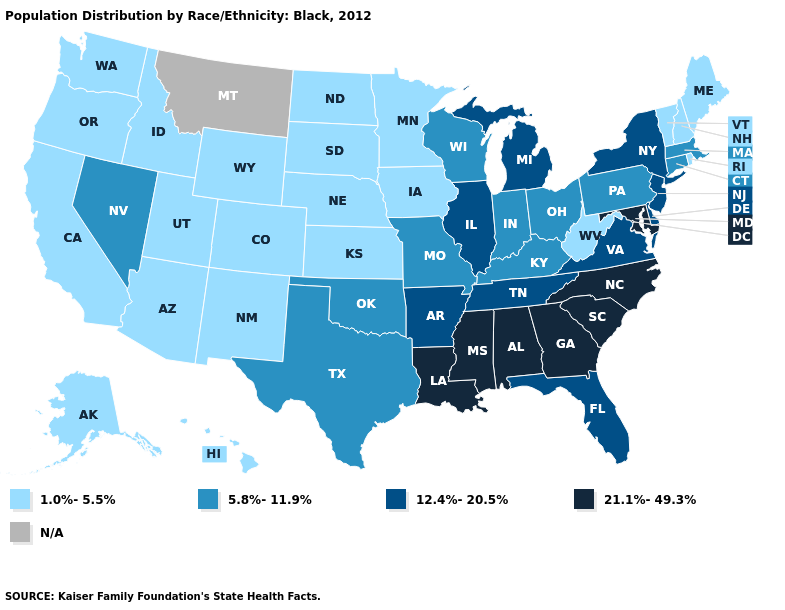What is the highest value in the USA?
Keep it brief. 21.1%-49.3%. Among the states that border Wisconsin , does Michigan have the highest value?
Short answer required. Yes. Name the states that have a value in the range 1.0%-5.5%?
Short answer required. Alaska, Arizona, California, Colorado, Hawaii, Idaho, Iowa, Kansas, Maine, Minnesota, Nebraska, New Hampshire, New Mexico, North Dakota, Oregon, Rhode Island, South Dakota, Utah, Vermont, Washington, West Virginia, Wyoming. Name the states that have a value in the range 5.8%-11.9%?
Be succinct. Connecticut, Indiana, Kentucky, Massachusetts, Missouri, Nevada, Ohio, Oklahoma, Pennsylvania, Texas, Wisconsin. Name the states that have a value in the range 12.4%-20.5%?
Concise answer only. Arkansas, Delaware, Florida, Illinois, Michigan, New Jersey, New York, Tennessee, Virginia. How many symbols are there in the legend?
Short answer required. 5. Name the states that have a value in the range N/A?
Quick response, please. Montana. Which states have the highest value in the USA?
Answer briefly. Alabama, Georgia, Louisiana, Maryland, Mississippi, North Carolina, South Carolina. Which states have the lowest value in the USA?
Quick response, please. Alaska, Arizona, California, Colorado, Hawaii, Idaho, Iowa, Kansas, Maine, Minnesota, Nebraska, New Hampshire, New Mexico, North Dakota, Oregon, Rhode Island, South Dakota, Utah, Vermont, Washington, West Virginia, Wyoming. What is the value of South Carolina?
Concise answer only. 21.1%-49.3%. Name the states that have a value in the range 1.0%-5.5%?
Be succinct. Alaska, Arizona, California, Colorado, Hawaii, Idaho, Iowa, Kansas, Maine, Minnesota, Nebraska, New Hampshire, New Mexico, North Dakota, Oregon, Rhode Island, South Dakota, Utah, Vermont, Washington, West Virginia, Wyoming. 